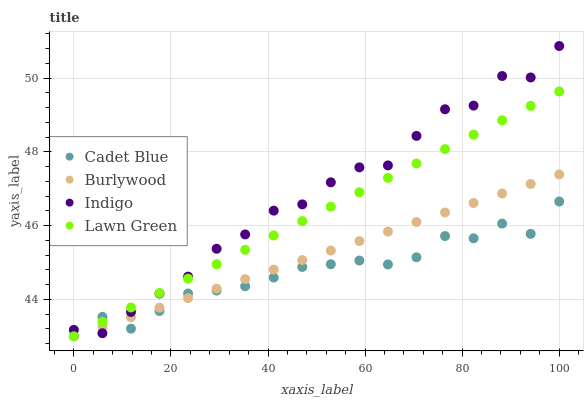Does Cadet Blue have the minimum area under the curve?
Answer yes or no. Yes. Does Indigo have the maximum area under the curve?
Answer yes or no. Yes. Does Lawn Green have the minimum area under the curve?
Answer yes or no. No. Does Lawn Green have the maximum area under the curve?
Answer yes or no. No. Is Burlywood the smoothest?
Answer yes or no. Yes. Is Indigo the roughest?
Answer yes or no. Yes. Is Lawn Green the smoothest?
Answer yes or no. No. Is Lawn Green the roughest?
Answer yes or no. No. Does Burlywood have the lowest value?
Answer yes or no. Yes. Does Indigo have the lowest value?
Answer yes or no. No. Does Indigo have the highest value?
Answer yes or no. Yes. Does Lawn Green have the highest value?
Answer yes or no. No. Does Indigo intersect Cadet Blue?
Answer yes or no. Yes. Is Indigo less than Cadet Blue?
Answer yes or no. No. Is Indigo greater than Cadet Blue?
Answer yes or no. No. 